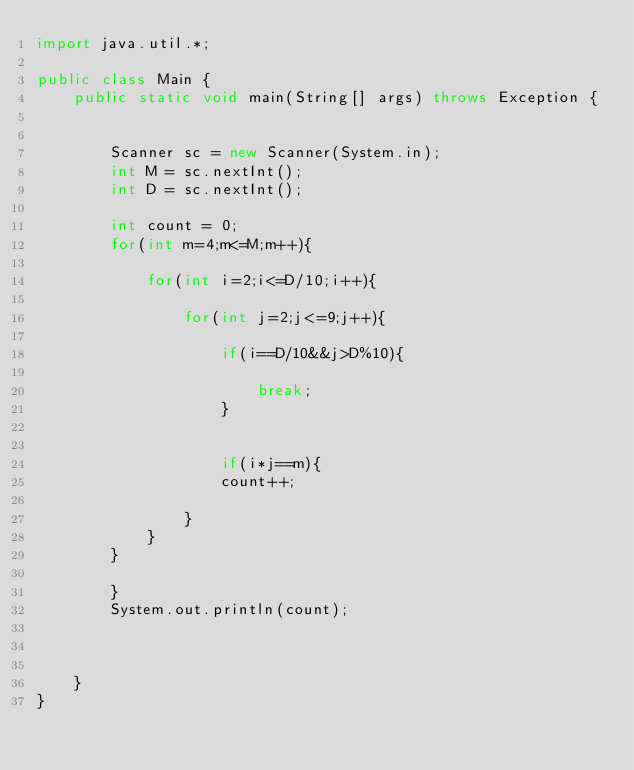Convert code to text. <code><loc_0><loc_0><loc_500><loc_500><_Java_>import java.util.*;

public class Main {
    public static void main(String[] args) throws Exception {
        
        
        Scanner sc = new Scanner(System.in);
        int M = sc.nextInt();
        int D = sc.nextInt();
        
        int count = 0;
        for(int m=4;m<=M;m++){
            
            for(int i=2;i<=D/10;i++){
                
                for(int j=2;j<=9;j++){
                    
                    if(i==D/10&&j>D%10){
                        
                        break;
                    }
                    
                    
                    if(i*j==m){
                    count++;
                    
                }
            }
        }
        
        }
        System.out.println(count);
        
        
        
    }
}
</code> 